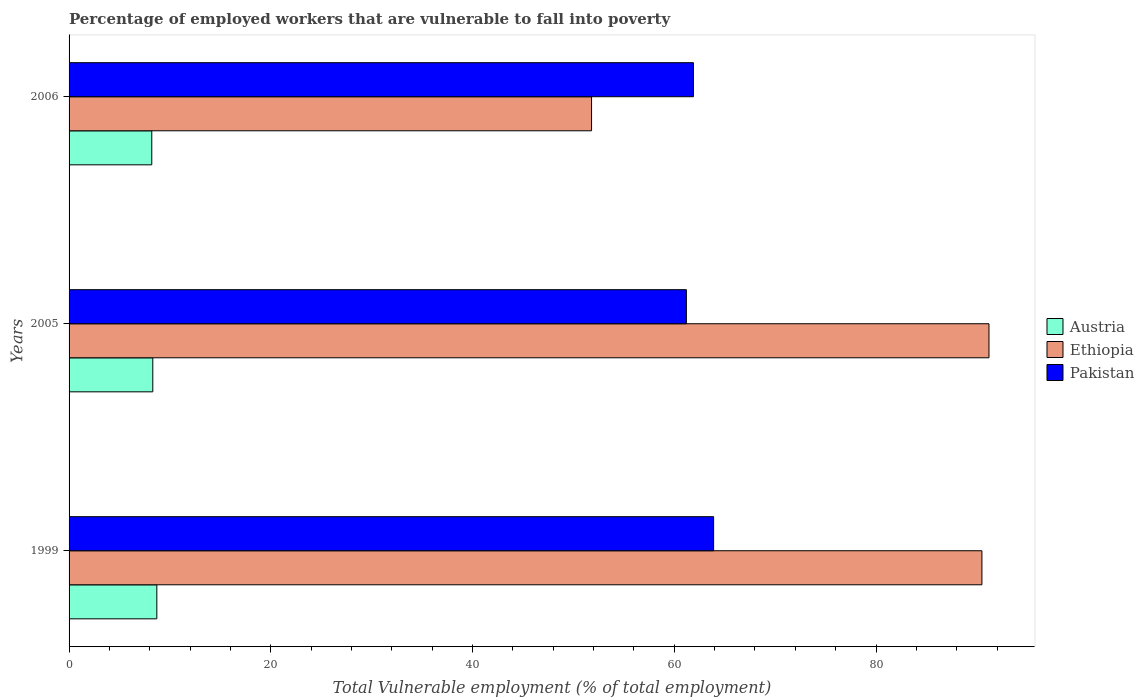How many different coloured bars are there?
Offer a very short reply. 3. How many bars are there on the 2nd tick from the top?
Offer a very short reply. 3. How many bars are there on the 2nd tick from the bottom?
Provide a short and direct response. 3. What is the percentage of employed workers who are vulnerable to fall into poverty in Ethiopia in 1999?
Your answer should be compact. 90.5. Across all years, what is the maximum percentage of employed workers who are vulnerable to fall into poverty in Pakistan?
Give a very brief answer. 63.9. Across all years, what is the minimum percentage of employed workers who are vulnerable to fall into poverty in Austria?
Your response must be concise. 8.2. In which year was the percentage of employed workers who are vulnerable to fall into poverty in Pakistan maximum?
Keep it short and to the point. 1999. In which year was the percentage of employed workers who are vulnerable to fall into poverty in Pakistan minimum?
Your answer should be very brief. 2005. What is the total percentage of employed workers who are vulnerable to fall into poverty in Austria in the graph?
Provide a short and direct response. 25.2. What is the difference between the percentage of employed workers who are vulnerable to fall into poverty in Ethiopia in 2005 and that in 2006?
Make the answer very short. 39.4. What is the difference between the percentage of employed workers who are vulnerable to fall into poverty in Pakistan in 2006 and the percentage of employed workers who are vulnerable to fall into poverty in Ethiopia in 2005?
Make the answer very short. -29.3. What is the average percentage of employed workers who are vulnerable to fall into poverty in Pakistan per year?
Offer a very short reply. 62.33. In the year 1999, what is the difference between the percentage of employed workers who are vulnerable to fall into poverty in Ethiopia and percentage of employed workers who are vulnerable to fall into poverty in Austria?
Ensure brevity in your answer.  81.8. What is the ratio of the percentage of employed workers who are vulnerable to fall into poverty in Pakistan in 2005 to that in 2006?
Offer a terse response. 0.99. What is the difference between the highest and the lowest percentage of employed workers who are vulnerable to fall into poverty in Pakistan?
Your response must be concise. 2.7. In how many years, is the percentage of employed workers who are vulnerable to fall into poverty in Ethiopia greater than the average percentage of employed workers who are vulnerable to fall into poverty in Ethiopia taken over all years?
Keep it short and to the point. 2. What does the 3rd bar from the bottom in 2006 represents?
Keep it short and to the point. Pakistan. Is it the case that in every year, the sum of the percentage of employed workers who are vulnerable to fall into poverty in Pakistan and percentage of employed workers who are vulnerable to fall into poverty in Austria is greater than the percentage of employed workers who are vulnerable to fall into poverty in Ethiopia?
Offer a terse response. No. Are the values on the major ticks of X-axis written in scientific E-notation?
Your response must be concise. No. Does the graph contain grids?
Offer a terse response. No. How many legend labels are there?
Make the answer very short. 3. How are the legend labels stacked?
Ensure brevity in your answer.  Vertical. What is the title of the graph?
Your answer should be compact. Percentage of employed workers that are vulnerable to fall into poverty. Does "Dominica" appear as one of the legend labels in the graph?
Keep it short and to the point. No. What is the label or title of the X-axis?
Offer a terse response. Total Vulnerable employment (% of total employment). What is the Total Vulnerable employment (% of total employment) in Austria in 1999?
Give a very brief answer. 8.7. What is the Total Vulnerable employment (% of total employment) of Ethiopia in 1999?
Offer a terse response. 90.5. What is the Total Vulnerable employment (% of total employment) of Pakistan in 1999?
Your response must be concise. 63.9. What is the Total Vulnerable employment (% of total employment) in Austria in 2005?
Your answer should be very brief. 8.3. What is the Total Vulnerable employment (% of total employment) in Ethiopia in 2005?
Make the answer very short. 91.2. What is the Total Vulnerable employment (% of total employment) in Pakistan in 2005?
Ensure brevity in your answer.  61.2. What is the Total Vulnerable employment (% of total employment) in Austria in 2006?
Offer a very short reply. 8.2. What is the Total Vulnerable employment (% of total employment) of Ethiopia in 2006?
Your answer should be very brief. 51.8. What is the Total Vulnerable employment (% of total employment) in Pakistan in 2006?
Make the answer very short. 61.9. Across all years, what is the maximum Total Vulnerable employment (% of total employment) in Austria?
Your answer should be very brief. 8.7. Across all years, what is the maximum Total Vulnerable employment (% of total employment) in Ethiopia?
Your answer should be very brief. 91.2. Across all years, what is the maximum Total Vulnerable employment (% of total employment) in Pakistan?
Give a very brief answer. 63.9. Across all years, what is the minimum Total Vulnerable employment (% of total employment) in Austria?
Offer a terse response. 8.2. Across all years, what is the minimum Total Vulnerable employment (% of total employment) of Ethiopia?
Give a very brief answer. 51.8. Across all years, what is the minimum Total Vulnerable employment (% of total employment) in Pakistan?
Offer a very short reply. 61.2. What is the total Total Vulnerable employment (% of total employment) in Austria in the graph?
Keep it short and to the point. 25.2. What is the total Total Vulnerable employment (% of total employment) in Ethiopia in the graph?
Your answer should be compact. 233.5. What is the total Total Vulnerable employment (% of total employment) in Pakistan in the graph?
Make the answer very short. 187. What is the difference between the Total Vulnerable employment (% of total employment) of Austria in 1999 and that in 2006?
Ensure brevity in your answer.  0.5. What is the difference between the Total Vulnerable employment (% of total employment) in Ethiopia in 1999 and that in 2006?
Keep it short and to the point. 38.7. What is the difference between the Total Vulnerable employment (% of total employment) of Ethiopia in 2005 and that in 2006?
Your answer should be compact. 39.4. What is the difference between the Total Vulnerable employment (% of total employment) of Austria in 1999 and the Total Vulnerable employment (% of total employment) of Ethiopia in 2005?
Ensure brevity in your answer.  -82.5. What is the difference between the Total Vulnerable employment (% of total employment) of Austria in 1999 and the Total Vulnerable employment (% of total employment) of Pakistan in 2005?
Provide a succinct answer. -52.5. What is the difference between the Total Vulnerable employment (% of total employment) in Ethiopia in 1999 and the Total Vulnerable employment (% of total employment) in Pakistan in 2005?
Provide a succinct answer. 29.3. What is the difference between the Total Vulnerable employment (% of total employment) in Austria in 1999 and the Total Vulnerable employment (% of total employment) in Ethiopia in 2006?
Ensure brevity in your answer.  -43.1. What is the difference between the Total Vulnerable employment (% of total employment) in Austria in 1999 and the Total Vulnerable employment (% of total employment) in Pakistan in 2006?
Your answer should be compact. -53.2. What is the difference between the Total Vulnerable employment (% of total employment) in Ethiopia in 1999 and the Total Vulnerable employment (% of total employment) in Pakistan in 2006?
Make the answer very short. 28.6. What is the difference between the Total Vulnerable employment (% of total employment) in Austria in 2005 and the Total Vulnerable employment (% of total employment) in Ethiopia in 2006?
Provide a succinct answer. -43.5. What is the difference between the Total Vulnerable employment (% of total employment) of Austria in 2005 and the Total Vulnerable employment (% of total employment) of Pakistan in 2006?
Your answer should be very brief. -53.6. What is the difference between the Total Vulnerable employment (% of total employment) of Ethiopia in 2005 and the Total Vulnerable employment (% of total employment) of Pakistan in 2006?
Keep it short and to the point. 29.3. What is the average Total Vulnerable employment (% of total employment) in Austria per year?
Offer a terse response. 8.4. What is the average Total Vulnerable employment (% of total employment) of Ethiopia per year?
Your response must be concise. 77.83. What is the average Total Vulnerable employment (% of total employment) in Pakistan per year?
Ensure brevity in your answer.  62.33. In the year 1999, what is the difference between the Total Vulnerable employment (% of total employment) in Austria and Total Vulnerable employment (% of total employment) in Ethiopia?
Ensure brevity in your answer.  -81.8. In the year 1999, what is the difference between the Total Vulnerable employment (% of total employment) of Austria and Total Vulnerable employment (% of total employment) of Pakistan?
Offer a terse response. -55.2. In the year 1999, what is the difference between the Total Vulnerable employment (% of total employment) of Ethiopia and Total Vulnerable employment (% of total employment) of Pakistan?
Your response must be concise. 26.6. In the year 2005, what is the difference between the Total Vulnerable employment (% of total employment) of Austria and Total Vulnerable employment (% of total employment) of Ethiopia?
Give a very brief answer. -82.9. In the year 2005, what is the difference between the Total Vulnerable employment (% of total employment) in Austria and Total Vulnerable employment (% of total employment) in Pakistan?
Your response must be concise. -52.9. In the year 2005, what is the difference between the Total Vulnerable employment (% of total employment) of Ethiopia and Total Vulnerable employment (% of total employment) of Pakistan?
Make the answer very short. 30. In the year 2006, what is the difference between the Total Vulnerable employment (% of total employment) in Austria and Total Vulnerable employment (% of total employment) in Ethiopia?
Your answer should be compact. -43.6. In the year 2006, what is the difference between the Total Vulnerable employment (% of total employment) in Austria and Total Vulnerable employment (% of total employment) in Pakistan?
Give a very brief answer. -53.7. What is the ratio of the Total Vulnerable employment (% of total employment) of Austria in 1999 to that in 2005?
Your response must be concise. 1.05. What is the ratio of the Total Vulnerable employment (% of total employment) of Pakistan in 1999 to that in 2005?
Provide a succinct answer. 1.04. What is the ratio of the Total Vulnerable employment (% of total employment) of Austria in 1999 to that in 2006?
Provide a succinct answer. 1.06. What is the ratio of the Total Vulnerable employment (% of total employment) in Ethiopia in 1999 to that in 2006?
Provide a short and direct response. 1.75. What is the ratio of the Total Vulnerable employment (% of total employment) of Pakistan in 1999 to that in 2006?
Your answer should be very brief. 1.03. What is the ratio of the Total Vulnerable employment (% of total employment) of Austria in 2005 to that in 2006?
Give a very brief answer. 1.01. What is the ratio of the Total Vulnerable employment (% of total employment) in Ethiopia in 2005 to that in 2006?
Provide a succinct answer. 1.76. What is the ratio of the Total Vulnerable employment (% of total employment) of Pakistan in 2005 to that in 2006?
Your answer should be compact. 0.99. What is the difference between the highest and the second highest Total Vulnerable employment (% of total employment) of Austria?
Keep it short and to the point. 0.4. What is the difference between the highest and the second highest Total Vulnerable employment (% of total employment) of Ethiopia?
Provide a succinct answer. 0.7. What is the difference between the highest and the lowest Total Vulnerable employment (% of total employment) of Austria?
Ensure brevity in your answer.  0.5. What is the difference between the highest and the lowest Total Vulnerable employment (% of total employment) of Ethiopia?
Your answer should be compact. 39.4. 